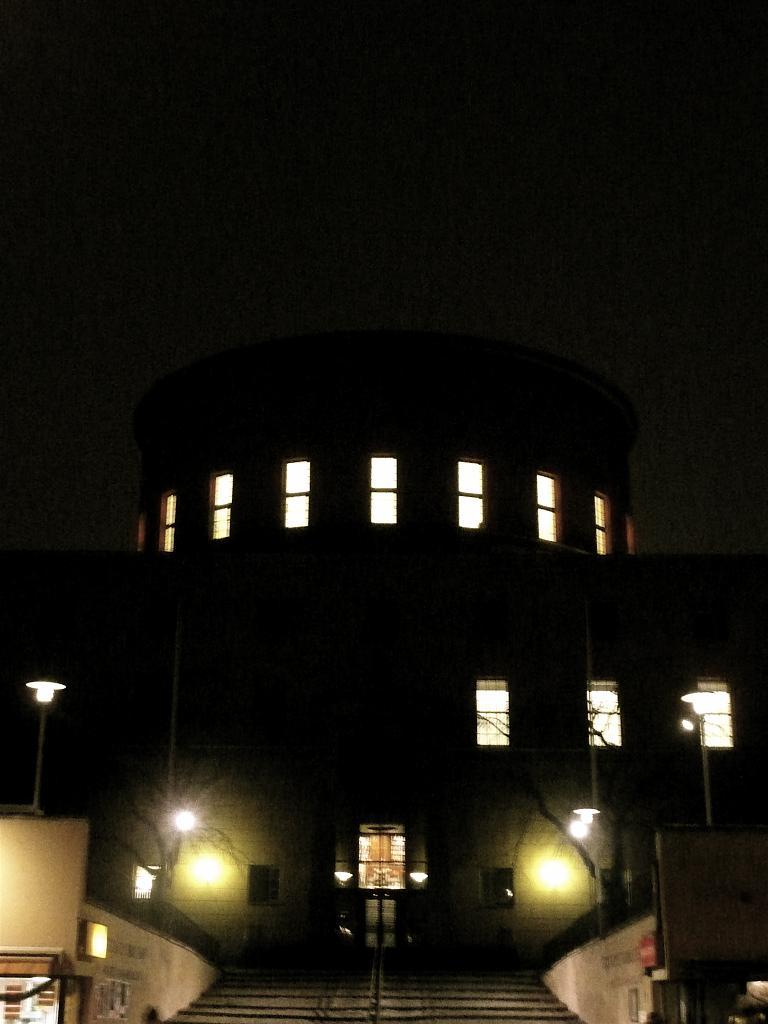What type of structure is present in the image? There is a building in the image. What feature can be seen on the building? The building has windows. What is located in front of the building? There are trees in front of the building. What else can be seen in the image besides the building and trees? There are poles with lights in the image. What is visible behind the building? The sky is visible behind the building. How much income does the cobweb on the building generate? There is no cobweb present in the image, so it is not possible to determine its income. 